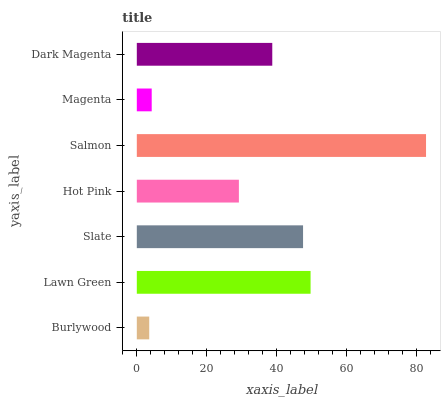Is Burlywood the minimum?
Answer yes or no. Yes. Is Salmon the maximum?
Answer yes or no. Yes. Is Lawn Green the minimum?
Answer yes or no. No. Is Lawn Green the maximum?
Answer yes or no. No. Is Lawn Green greater than Burlywood?
Answer yes or no. Yes. Is Burlywood less than Lawn Green?
Answer yes or no. Yes. Is Burlywood greater than Lawn Green?
Answer yes or no. No. Is Lawn Green less than Burlywood?
Answer yes or no. No. Is Dark Magenta the high median?
Answer yes or no. Yes. Is Dark Magenta the low median?
Answer yes or no. Yes. Is Hot Pink the high median?
Answer yes or no. No. Is Burlywood the low median?
Answer yes or no. No. 